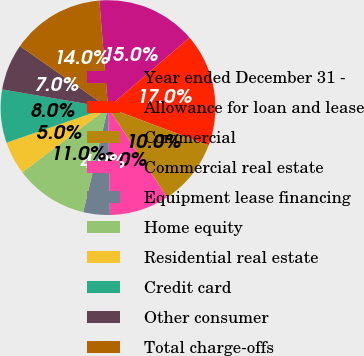<chart> <loc_0><loc_0><loc_500><loc_500><pie_chart><fcel>Year ended December 31 -<fcel>Allowance for loan and lease<fcel>Commercial<fcel>Commercial real estate<fcel>Equipment lease financing<fcel>Home equity<fcel>Residential real estate<fcel>Credit card<fcel>Other consumer<fcel>Total charge-offs<nl><fcel>15.0%<fcel>17.0%<fcel>10.0%<fcel>9.0%<fcel>4.0%<fcel>11.0%<fcel>5.0%<fcel>8.0%<fcel>7.0%<fcel>14.0%<nl></chart> 